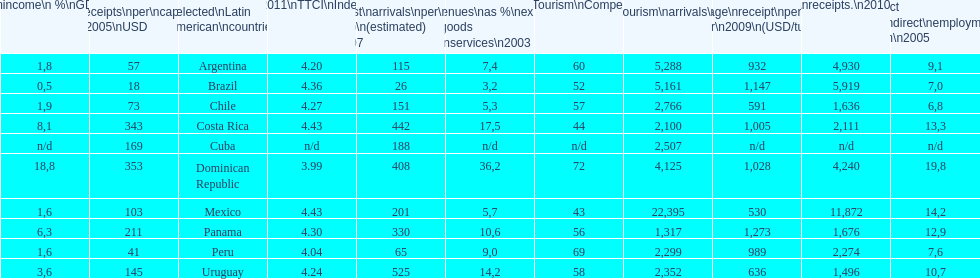What country had the least arrivals per 1000 inhabitants in 2007(estimated)? Brazil. 